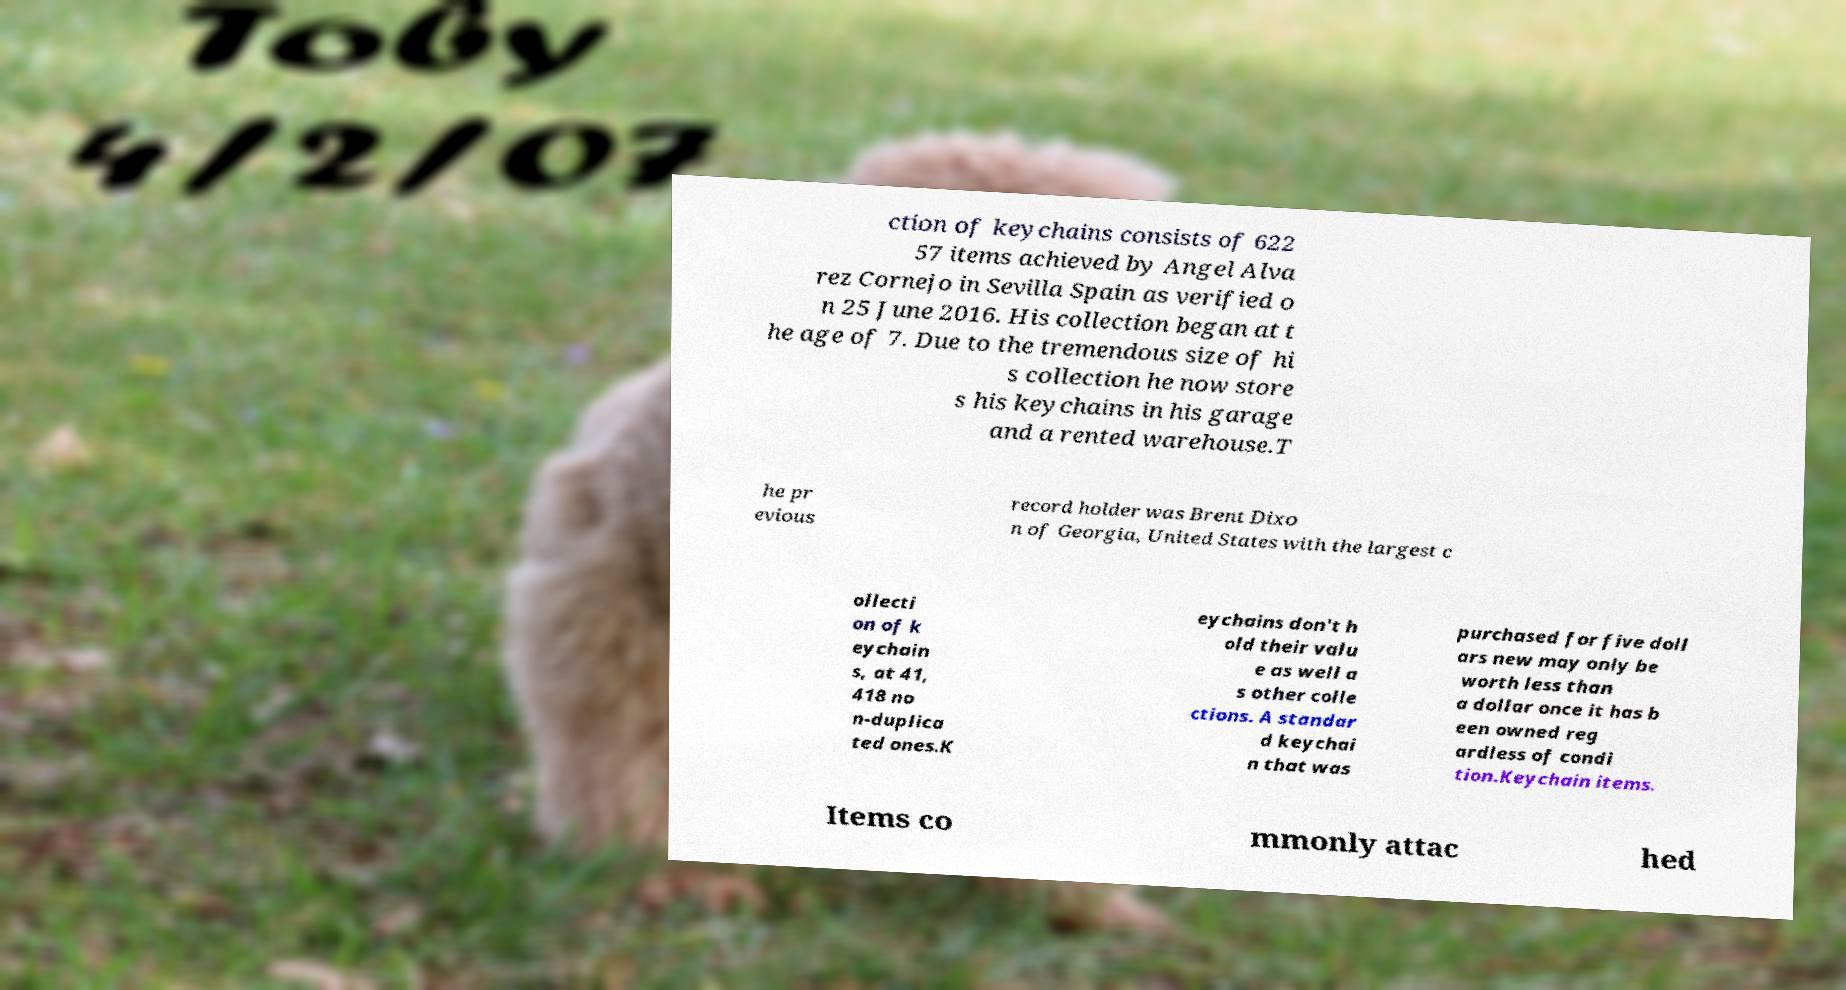Could you extract and type out the text from this image? ction of keychains consists of 622 57 items achieved by Angel Alva rez Cornejo in Sevilla Spain as verified o n 25 June 2016. His collection began at t he age of 7. Due to the tremendous size of hi s collection he now store s his keychains in his garage and a rented warehouse.T he pr evious record holder was Brent Dixo n of Georgia, United States with the largest c ollecti on of k eychain s, at 41, 418 no n-duplica ted ones.K eychains don't h old their valu e as well a s other colle ctions. A standar d keychai n that was purchased for five doll ars new may only be worth less than a dollar once it has b een owned reg ardless of condi tion.Keychain items. Items co mmonly attac hed 